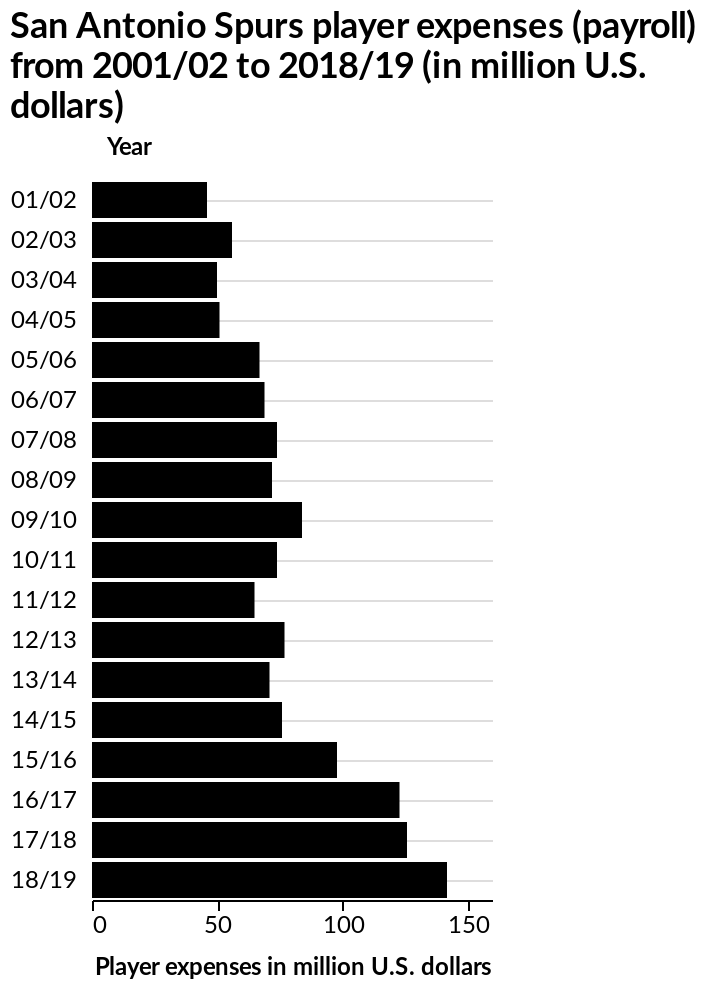<image>
Offer a thorough analysis of the image. Player expenses are at their highest in 2018/19. Player expenses have be gradually rising over the years with slight decreases in 2003/04, 2008/09 2010/2011, 2011/12 & 2013/14. The largest increase was seen in 2016/17. What is the range of the y-axis on the bar chart? The range of the y-axis on the bar chart is from 2001/02 to 2018/19. 